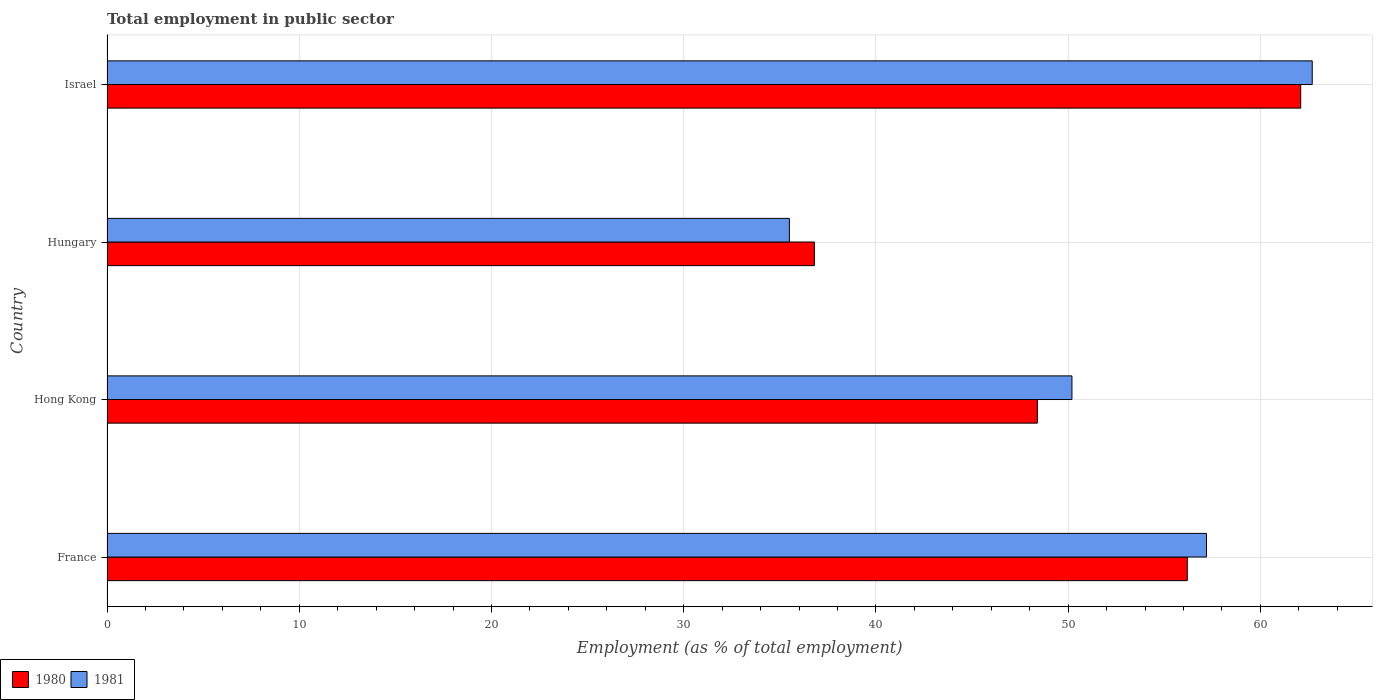How many different coloured bars are there?
Give a very brief answer. 2. Are the number of bars per tick equal to the number of legend labels?
Offer a very short reply. Yes. How many bars are there on the 3rd tick from the top?
Provide a succinct answer. 2. How many bars are there on the 2nd tick from the bottom?
Offer a terse response. 2. What is the label of the 2nd group of bars from the top?
Your answer should be compact. Hungary. What is the employment in public sector in 1980 in Hungary?
Your answer should be very brief. 36.8. Across all countries, what is the maximum employment in public sector in 1980?
Offer a very short reply. 62.1. Across all countries, what is the minimum employment in public sector in 1981?
Your answer should be very brief. 35.5. In which country was the employment in public sector in 1980 maximum?
Your answer should be compact. Israel. In which country was the employment in public sector in 1980 minimum?
Provide a short and direct response. Hungary. What is the total employment in public sector in 1980 in the graph?
Offer a very short reply. 203.5. What is the difference between the employment in public sector in 1981 in Hungary and that in Israel?
Give a very brief answer. -27.2. What is the difference between the employment in public sector in 1981 in Hungary and the employment in public sector in 1980 in France?
Provide a succinct answer. -20.7. What is the average employment in public sector in 1981 per country?
Keep it short and to the point. 51.4. What is the difference between the employment in public sector in 1980 and employment in public sector in 1981 in Hong Kong?
Make the answer very short. -1.8. In how many countries, is the employment in public sector in 1980 greater than 40 %?
Your response must be concise. 3. What is the ratio of the employment in public sector in 1980 in Hong Kong to that in Hungary?
Offer a terse response. 1.32. What is the difference between the highest and the second highest employment in public sector in 1980?
Provide a short and direct response. 5.9. What is the difference between the highest and the lowest employment in public sector in 1980?
Offer a terse response. 25.3. Is the sum of the employment in public sector in 1980 in France and Hungary greater than the maximum employment in public sector in 1981 across all countries?
Offer a very short reply. Yes. What does the 1st bar from the top in France represents?
Offer a very short reply. 1981. What does the 2nd bar from the bottom in Hong Kong represents?
Your answer should be very brief. 1981. How many countries are there in the graph?
Provide a short and direct response. 4. Does the graph contain any zero values?
Make the answer very short. No. Where does the legend appear in the graph?
Give a very brief answer. Bottom left. How are the legend labels stacked?
Ensure brevity in your answer.  Horizontal. What is the title of the graph?
Ensure brevity in your answer.  Total employment in public sector. What is the label or title of the X-axis?
Your answer should be very brief. Employment (as % of total employment). What is the label or title of the Y-axis?
Make the answer very short. Country. What is the Employment (as % of total employment) in 1980 in France?
Ensure brevity in your answer.  56.2. What is the Employment (as % of total employment) of 1981 in France?
Give a very brief answer. 57.2. What is the Employment (as % of total employment) in 1980 in Hong Kong?
Provide a short and direct response. 48.4. What is the Employment (as % of total employment) of 1981 in Hong Kong?
Make the answer very short. 50.2. What is the Employment (as % of total employment) in 1980 in Hungary?
Your answer should be very brief. 36.8. What is the Employment (as % of total employment) of 1981 in Hungary?
Offer a very short reply. 35.5. What is the Employment (as % of total employment) in 1980 in Israel?
Provide a succinct answer. 62.1. What is the Employment (as % of total employment) of 1981 in Israel?
Your answer should be compact. 62.7. Across all countries, what is the maximum Employment (as % of total employment) in 1980?
Offer a very short reply. 62.1. Across all countries, what is the maximum Employment (as % of total employment) of 1981?
Make the answer very short. 62.7. Across all countries, what is the minimum Employment (as % of total employment) in 1980?
Your response must be concise. 36.8. Across all countries, what is the minimum Employment (as % of total employment) in 1981?
Keep it short and to the point. 35.5. What is the total Employment (as % of total employment) in 1980 in the graph?
Your response must be concise. 203.5. What is the total Employment (as % of total employment) in 1981 in the graph?
Your answer should be very brief. 205.6. What is the difference between the Employment (as % of total employment) in 1980 in France and that in Hong Kong?
Your answer should be compact. 7.8. What is the difference between the Employment (as % of total employment) of 1981 in France and that in Hong Kong?
Provide a succinct answer. 7. What is the difference between the Employment (as % of total employment) of 1980 in France and that in Hungary?
Keep it short and to the point. 19.4. What is the difference between the Employment (as % of total employment) of 1981 in France and that in Hungary?
Make the answer very short. 21.7. What is the difference between the Employment (as % of total employment) of 1980 in France and that in Israel?
Offer a terse response. -5.9. What is the difference between the Employment (as % of total employment) of 1981 in Hong Kong and that in Hungary?
Keep it short and to the point. 14.7. What is the difference between the Employment (as % of total employment) of 1980 in Hong Kong and that in Israel?
Your response must be concise. -13.7. What is the difference between the Employment (as % of total employment) in 1981 in Hong Kong and that in Israel?
Your answer should be compact. -12.5. What is the difference between the Employment (as % of total employment) of 1980 in Hungary and that in Israel?
Provide a short and direct response. -25.3. What is the difference between the Employment (as % of total employment) in 1981 in Hungary and that in Israel?
Offer a terse response. -27.2. What is the difference between the Employment (as % of total employment) in 1980 in France and the Employment (as % of total employment) in 1981 in Hungary?
Your answer should be compact. 20.7. What is the difference between the Employment (as % of total employment) in 1980 in France and the Employment (as % of total employment) in 1981 in Israel?
Provide a succinct answer. -6.5. What is the difference between the Employment (as % of total employment) in 1980 in Hong Kong and the Employment (as % of total employment) in 1981 in Israel?
Offer a terse response. -14.3. What is the difference between the Employment (as % of total employment) in 1980 in Hungary and the Employment (as % of total employment) in 1981 in Israel?
Give a very brief answer. -25.9. What is the average Employment (as % of total employment) in 1980 per country?
Your answer should be compact. 50.88. What is the average Employment (as % of total employment) in 1981 per country?
Provide a short and direct response. 51.4. What is the difference between the Employment (as % of total employment) of 1980 and Employment (as % of total employment) of 1981 in France?
Offer a terse response. -1. What is the difference between the Employment (as % of total employment) in 1980 and Employment (as % of total employment) in 1981 in Hungary?
Provide a succinct answer. 1.3. What is the difference between the Employment (as % of total employment) in 1980 and Employment (as % of total employment) in 1981 in Israel?
Offer a very short reply. -0.6. What is the ratio of the Employment (as % of total employment) of 1980 in France to that in Hong Kong?
Your answer should be compact. 1.16. What is the ratio of the Employment (as % of total employment) of 1981 in France to that in Hong Kong?
Keep it short and to the point. 1.14. What is the ratio of the Employment (as % of total employment) of 1980 in France to that in Hungary?
Ensure brevity in your answer.  1.53. What is the ratio of the Employment (as % of total employment) of 1981 in France to that in Hungary?
Provide a succinct answer. 1.61. What is the ratio of the Employment (as % of total employment) in 1980 in France to that in Israel?
Your response must be concise. 0.91. What is the ratio of the Employment (as % of total employment) of 1981 in France to that in Israel?
Your response must be concise. 0.91. What is the ratio of the Employment (as % of total employment) in 1980 in Hong Kong to that in Hungary?
Provide a succinct answer. 1.32. What is the ratio of the Employment (as % of total employment) of 1981 in Hong Kong to that in Hungary?
Keep it short and to the point. 1.41. What is the ratio of the Employment (as % of total employment) of 1980 in Hong Kong to that in Israel?
Give a very brief answer. 0.78. What is the ratio of the Employment (as % of total employment) of 1981 in Hong Kong to that in Israel?
Provide a short and direct response. 0.8. What is the ratio of the Employment (as % of total employment) of 1980 in Hungary to that in Israel?
Provide a succinct answer. 0.59. What is the ratio of the Employment (as % of total employment) of 1981 in Hungary to that in Israel?
Provide a succinct answer. 0.57. What is the difference between the highest and the second highest Employment (as % of total employment) in 1981?
Offer a terse response. 5.5. What is the difference between the highest and the lowest Employment (as % of total employment) of 1980?
Ensure brevity in your answer.  25.3. What is the difference between the highest and the lowest Employment (as % of total employment) in 1981?
Make the answer very short. 27.2. 